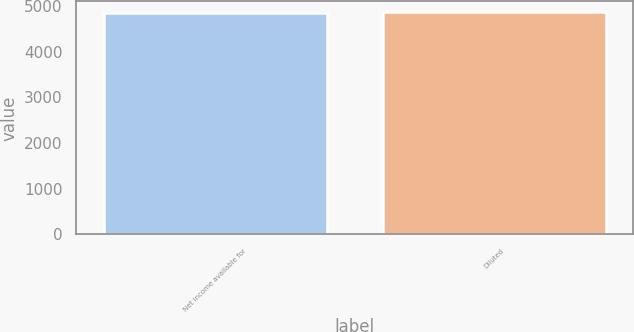Convert chart to OTSL. <chart><loc_0><loc_0><loc_500><loc_500><bar_chart><fcel>Net income available for<fcel>Diluted<nl><fcel>4853<fcel>4857<nl></chart> 